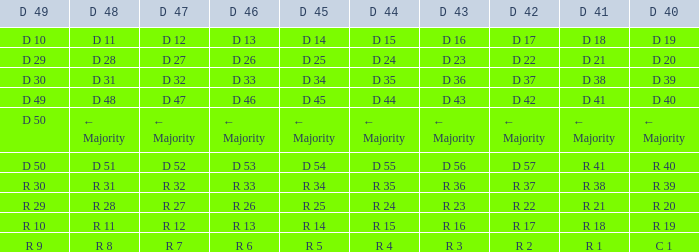I desire the d 40 with d 44 of d 15 D 19. 